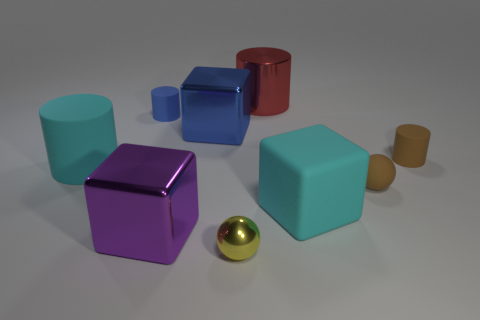Are there more big matte cubes than yellow shiny cylinders?
Provide a short and direct response. Yes. Is the shape of the large cyan thing right of the large red cylinder the same as  the yellow thing?
Give a very brief answer. No. What number of metallic objects are either tiny blue cylinders or small brown blocks?
Keep it short and to the point. 0. Is there another big object made of the same material as the yellow object?
Your answer should be compact. Yes. What material is the large purple thing?
Offer a very short reply. Metal. The small thing that is in front of the cyan object to the right of the large blue metal thing that is on the left side of the big red object is what shape?
Your response must be concise. Sphere. Is the number of cylinders in front of the brown rubber cylinder greater than the number of blue shiny balls?
Offer a very short reply. Yes. Does the red thing have the same shape as the big cyan thing left of the purple cube?
Make the answer very short. Yes. There is a thing that is the same color as the large matte cylinder; what shape is it?
Your response must be concise. Cube. What number of purple metallic objects are in front of the small matte cylinder on the left side of the rubber cylinder that is right of the large purple cube?
Your answer should be very brief. 1. 